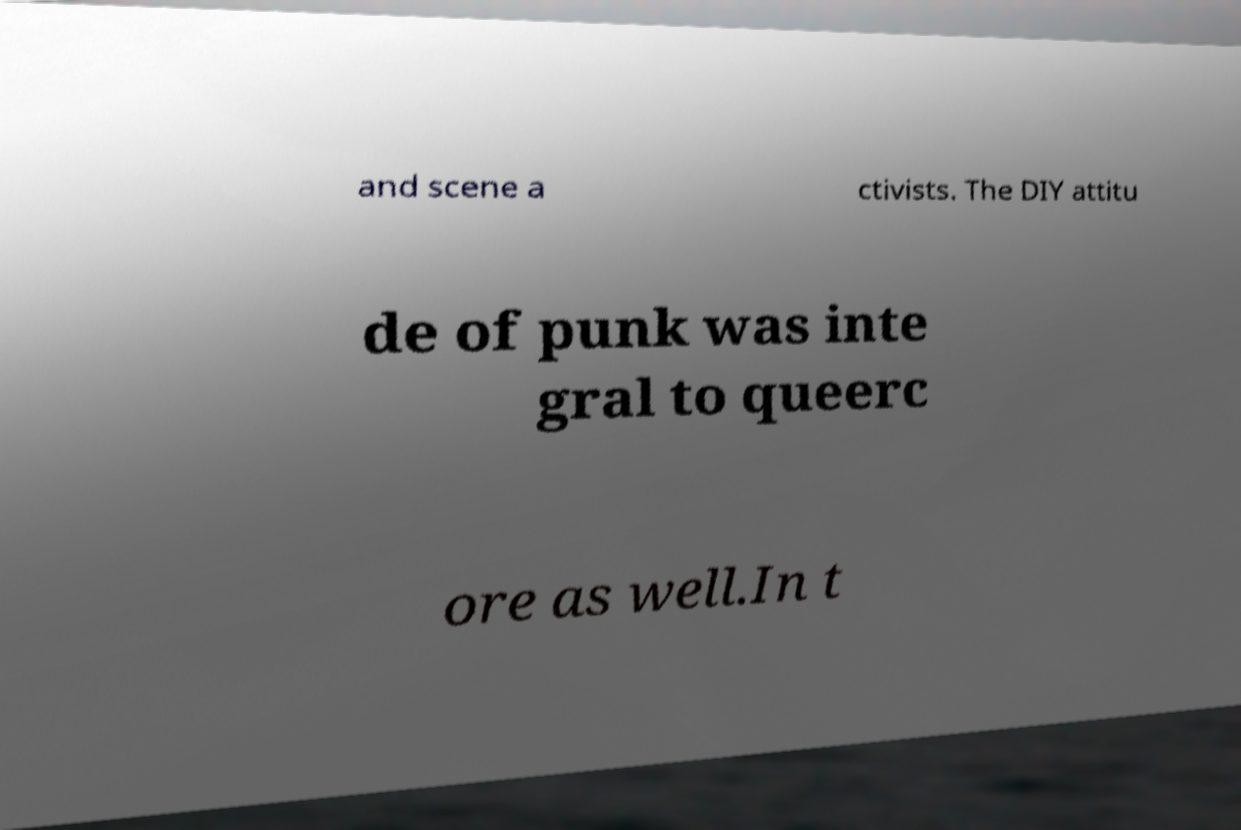Can you read and provide the text displayed in the image?This photo seems to have some interesting text. Can you extract and type it out for me? and scene a ctivists. The DIY attitu de of punk was inte gral to queerc ore as well.In t 